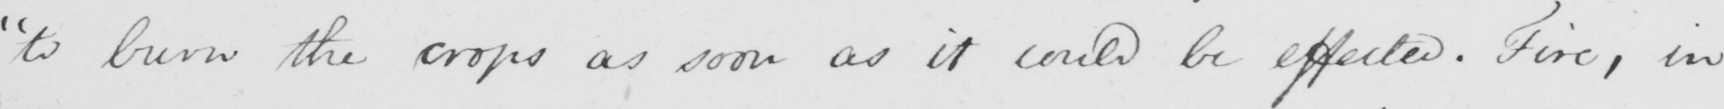Transcribe the text shown in this historical manuscript line. " to burn the crops as soon as it could be effected . Fire , in 